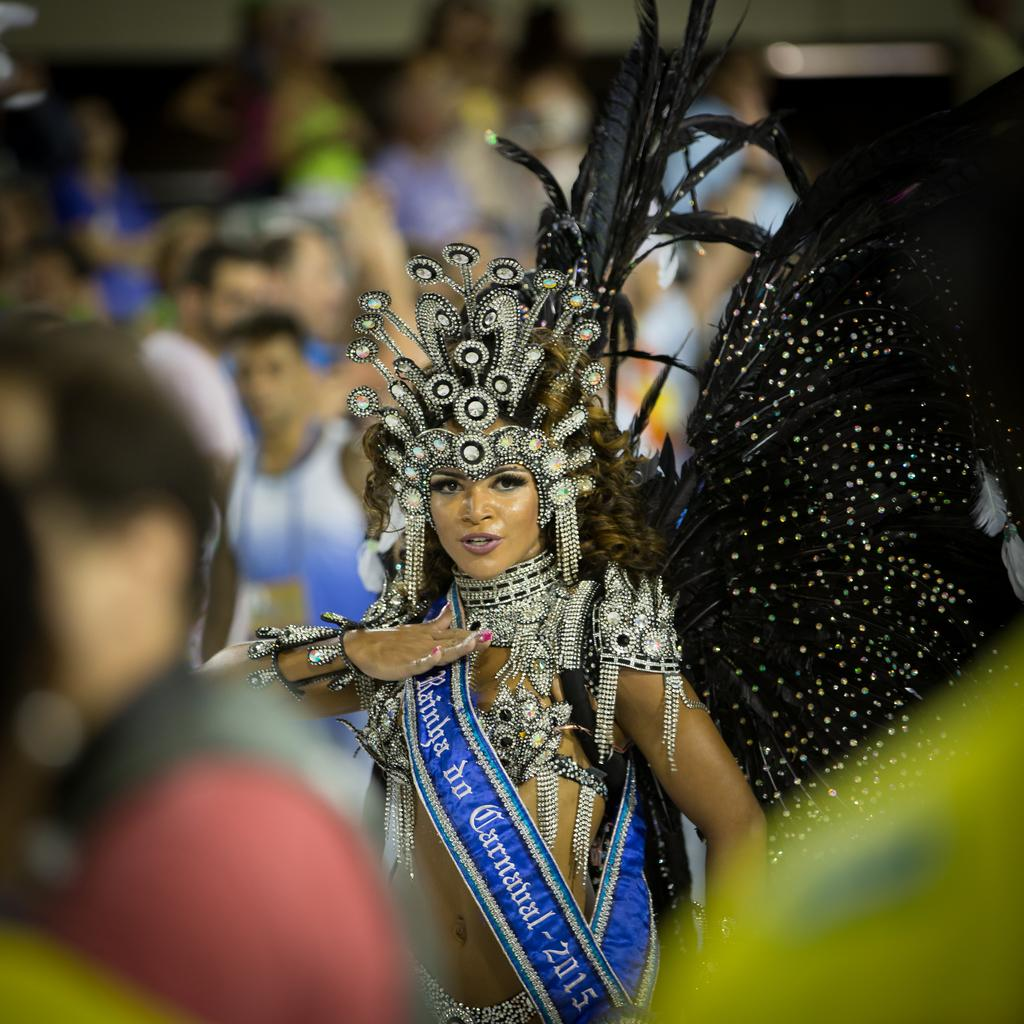Who is the main subject in the image? There is a lady in the image. What is the lady wearing? The lady is wearing a costume. What details can be seen on the costume? The costume has text and a number on it. Can you describe the background of the image? There are people in the background of the image, but they are blurry. What type of toothbrush is the lady using in the image? There is no toothbrush present in the image. Can you describe the bushes in the background of the image? There are no bushes visible in the image; the background features blurry people. 